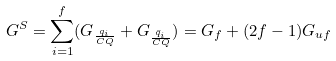<formula> <loc_0><loc_0><loc_500><loc_500>G ^ { S } = \sum ^ { f } _ { i = 1 } ( G _ { \frac { q _ { i } } { C Q } } + G _ { \frac { \bar { q } _ { i } } { C Q } } ) = G _ { f } + ( 2 f - 1 ) G _ { u f }</formula> 